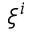Convert formula to latex. <formula><loc_0><loc_0><loc_500><loc_500>\xi ^ { i }</formula> 